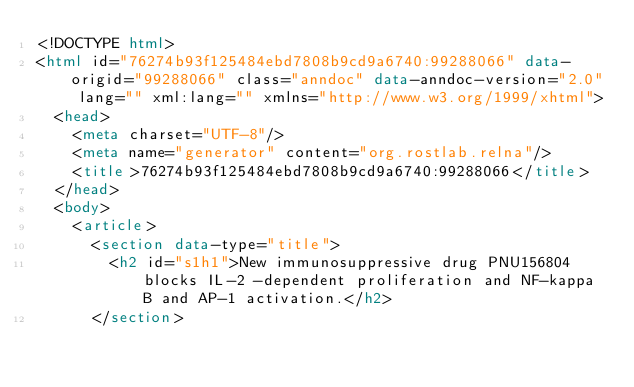<code> <loc_0><loc_0><loc_500><loc_500><_HTML_><!DOCTYPE html>
<html id="76274b93f125484ebd7808b9cd9a6740:99288066" data-origid="99288066" class="anndoc" data-anndoc-version="2.0" lang="" xml:lang="" xmlns="http://www.w3.org/1999/xhtml">
	<head>
		<meta charset="UTF-8"/>
		<meta name="generator" content="org.rostlab.relna"/>
		<title>76274b93f125484ebd7808b9cd9a6740:99288066</title>
	</head>
	<body>
		<article>
			<section data-type="title">
				<h2 id="s1h1">New immunosuppressive drug PNU156804 blocks IL-2 -dependent proliferation and NF-kappa B and AP-1 activation.</h2>
			</section></code> 